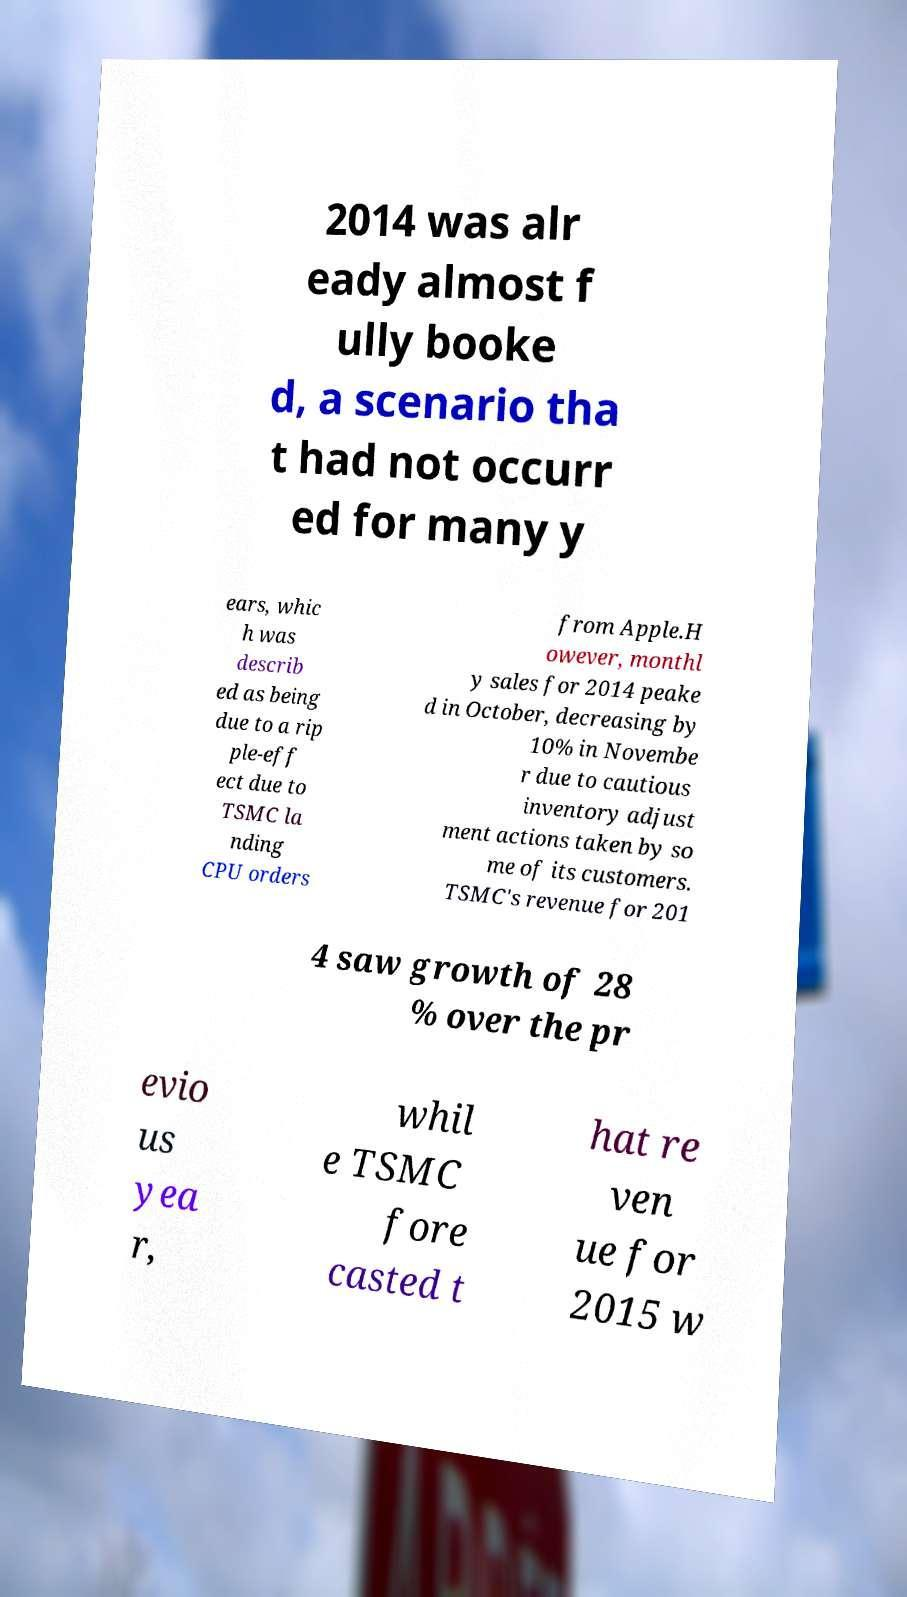I need the written content from this picture converted into text. Can you do that? 2014 was alr eady almost f ully booke d, a scenario tha t had not occurr ed for many y ears, whic h was describ ed as being due to a rip ple-eff ect due to TSMC la nding CPU orders from Apple.H owever, monthl y sales for 2014 peake d in October, decreasing by 10% in Novembe r due to cautious inventory adjust ment actions taken by so me of its customers. TSMC's revenue for 201 4 saw growth of 28 % over the pr evio us yea r, whil e TSMC fore casted t hat re ven ue for 2015 w 